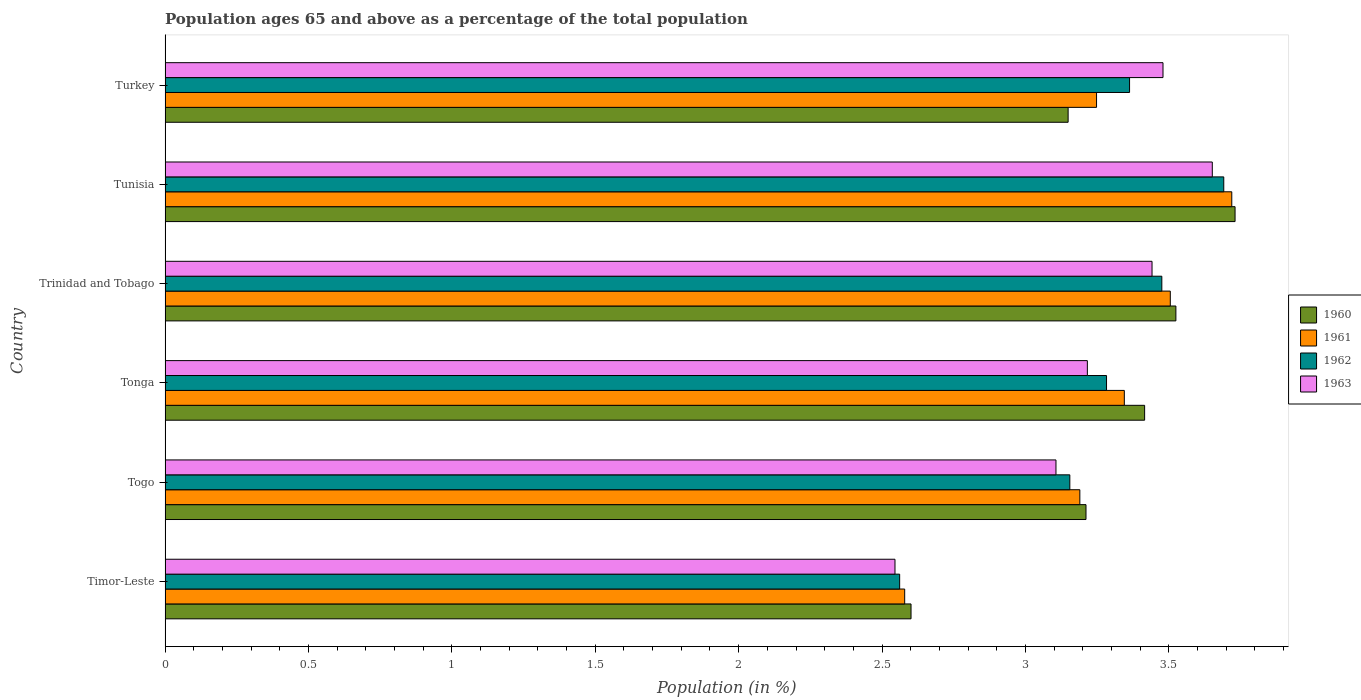How many groups of bars are there?
Keep it short and to the point. 6. Are the number of bars on each tick of the Y-axis equal?
Your answer should be compact. Yes. What is the label of the 3rd group of bars from the top?
Your response must be concise. Trinidad and Tobago. What is the percentage of the population ages 65 and above in 1963 in Timor-Leste?
Provide a succinct answer. 2.55. Across all countries, what is the maximum percentage of the population ages 65 and above in 1960?
Make the answer very short. 3.73. Across all countries, what is the minimum percentage of the population ages 65 and above in 1963?
Offer a very short reply. 2.55. In which country was the percentage of the population ages 65 and above in 1960 maximum?
Your response must be concise. Tunisia. In which country was the percentage of the population ages 65 and above in 1963 minimum?
Offer a terse response. Timor-Leste. What is the total percentage of the population ages 65 and above in 1963 in the graph?
Provide a short and direct response. 19.44. What is the difference between the percentage of the population ages 65 and above in 1962 in Timor-Leste and that in Tonga?
Provide a short and direct response. -0.72. What is the difference between the percentage of the population ages 65 and above in 1962 in Togo and the percentage of the population ages 65 and above in 1961 in Trinidad and Tobago?
Ensure brevity in your answer.  -0.35. What is the average percentage of the population ages 65 and above in 1963 per country?
Offer a terse response. 3.24. What is the difference between the percentage of the population ages 65 and above in 1963 and percentage of the population ages 65 and above in 1960 in Trinidad and Tobago?
Your answer should be very brief. -0.08. In how many countries, is the percentage of the population ages 65 and above in 1960 greater than 0.30000000000000004 ?
Keep it short and to the point. 6. What is the ratio of the percentage of the population ages 65 and above in 1963 in Togo to that in Tunisia?
Provide a short and direct response. 0.85. Is the percentage of the population ages 65 and above in 1962 in Tonga less than that in Turkey?
Offer a terse response. Yes. Is the difference between the percentage of the population ages 65 and above in 1963 in Timor-Leste and Trinidad and Tobago greater than the difference between the percentage of the population ages 65 and above in 1960 in Timor-Leste and Trinidad and Tobago?
Your answer should be compact. Yes. What is the difference between the highest and the second highest percentage of the population ages 65 and above in 1963?
Offer a terse response. 0.17. What is the difference between the highest and the lowest percentage of the population ages 65 and above in 1962?
Ensure brevity in your answer.  1.13. In how many countries, is the percentage of the population ages 65 and above in 1960 greater than the average percentage of the population ages 65 and above in 1960 taken over all countries?
Your response must be concise. 3. What does the 2nd bar from the bottom in Turkey represents?
Keep it short and to the point. 1961. How many bars are there?
Provide a short and direct response. 24. Does the graph contain any zero values?
Your response must be concise. No. Does the graph contain grids?
Provide a succinct answer. No. Where does the legend appear in the graph?
Your response must be concise. Center right. How many legend labels are there?
Your answer should be very brief. 4. How are the legend labels stacked?
Give a very brief answer. Vertical. What is the title of the graph?
Make the answer very short. Population ages 65 and above as a percentage of the total population. What is the label or title of the X-axis?
Your response must be concise. Population (in %). What is the label or title of the Y-axis?
Offer a very short reply. Country. What is the Population (in %) in 1960 in Timor-Leste?
Your answer should be compact. 2.6. What is the Population (in %) of 1961 in Timor-Leste?
Offer a very short reply. 2.58. What is the Population (in %) in 1962 in Timor-Leste?
Your response must be concise. 2.56. What is the Population (in %) in 1963 in Timor-Leste?
Provide a succinct answer. 2.55. What is the Population (in %) of 1960 in Togo?
Offer a very short reply. 3.21. What is the Population (in %) in 1961 in Togo?
Your response must be concise. 3.19. What is the Population (in %) in 1962 in Togo?
Your response must be concise. 3.15. What is the Population (in %) in 1963 in Togo?
Your response must be concise. 3.11. What is the Population (in %) of 1960 in Tonga?
Give a very brief answer. 3.42. What is the Population (in %) of 1961 in Tonga?
Offer a very short reply. 3.34. What is the Population (in %) of 1962 in Tonga?
Provide a succinct answer. 3.28. What is the Population (in %) in 1963 in Tonga?
Give a very brief answer. 3.22. What is the Population (in %) of 1960 in Trinidad and Tobago?
Offer a terse response. 3.52. What is the Population (in %) of 1961 in Trinidad and Tobago?
Provide a succinct answer. 3.51. What is the Population (in %) in 1962 in Trinidad and Tobago?
Ensure brevity in your answer.  3.48. What is the Population (in %) of 1963 in Trinidad and Tobago?
Give a very brief answer. 3.44. What is the Population (in %) in 1960 in Tunisia?
Give a very brief answer. 3.73. What is the Population (in %) of 1961 in Tunisia?
Provide a short and direct response. 3.72. What is the Population (in %) in 1962 in Tunisia?
Your answer should be very brief. 3.69. What is the Population (in %) of 1963 in Tunisia?
Offer a very short reply. 3.65. What is the Population (in %) of 1960 in Turkey?
Provide a short and direct response. 3.15. What is the Population (in %) in 1961 in Turkey?
Provide a short and direct response. 3.25. What is the Population (in %) in 1962 in Turkey?
Keep it short and to the point. 3.36. What is the Population (in %) in 1963 in Turkey?
Your answer should be very brief. 3.48. Across all countries, what is the maximum Population (in %) in 1960?
Give a very brief answer. 3.73. Across all countries, what is the maximum Population (in %) in 1961?
Provide a succinct answer. 3.72. Across all countries, what is the maximum Population (in %) of 1962?
Provide a short and direct response. 3.69. Across all countries, what is the maximum Population (in %) in 1963?
Ensure brevity in your answer.  3.65. Across all countries, what is the minimum Population (in %) in 1960?
Provide a short and direct response. 2.6. Across all countries, what is the minimum Population (in %) of 1961?
Keep it short and to the point. 2.58. Across all countries, what is the minimum Population (in %) of 1962?
Provide a short and direct response. 2.56. Across all countries, what is the minimum Population (in %) of 1963?
Offer a very short reply. 2.55. What is the total Population (in %) of 1960 in the graph?
Your answer should be compact. 19.63. What is the total Population (in %) in 1961 in the graph?
Keep it short and to the point. 19.59. What is the total Population (in %) of 1962 in the graph?
Offer a terse response. 19.53. What is the total Population (in %) in 1963 in the graph?
Offer a terse response. 19.44. What is the difference between the Population (in %) in 1960 in Timor-Leste and that in Togo?
Give a very brief answer. -0.61. What is the difference between the Population (in %) in 1961 in Timor-Leste and that in Togo?
Provide a short and direct response. -0.61. What is the difference between the Population (in %) of 1962 in Timor-Leste and that in Togo?
Make the answer very short. -0.59. What is the difference between the Population (in %) in 1963 in Timor-Leste and that in Togo?
Offer a terse response. -0.56. What is the difference between the Population (in %) in 1960 in Timor-Leste and that in Tonga?
Your answer should be compact. -0.81. What is the difference between the Population (in %) of 1961 in Timor-Leste and that in Tonga?
Provide a succinct answer. -0.77. What is the difference between the Population (in %) in 1962 in Timor-Leste and that in Tonga?
Make the answer very short. -0.72. What is the difference between the Population (in %) of 1963 in Timor-Leste and that in Tonga?
Give a very brief answer. -0.67. What is the difference between the Population (in %) of 1960 in Timor-Leste and that in Trinidad and Tobago?
Provide a succinct answer. -0.92. What is the difference between the Population (in %) in 1961 in Timor-Leste and that in Trinidad and Tobago?
Provide a succinct answer. -0.93. What is the difference between the Population (in %) of 1962 in Timor-Leste and that in Trinidad and Tobago?
Offer a terse response. -0.91. What is the difference between the Population (in %) of 1963 in Timor-Leste and that in Trinidad and Tobago?
Your response must be concise. -0.9. What is the difference between the Population (in %) of 1960 in Timor-Leste and that in Tunisia?
Your answer should be very brief. -1.13. What is the difference between the Population (in %) in 1961 in Timor-Leste and that in Tunisia?
Make the answer very short. -1.14. What is the difference between the Population (in %) of 1962 in Timor-Leste and that in Tunisia?
Provide a succinct answer. -1.13. What is the difference between the Population (in %) in 1963 in Timor-Leste and that in Tunisia?
Offer a terse response. -1.11. What is the difference between the Population (in %) in 1960 in Timor-Leste and that in Turkey?
Provide a short and direct response. -0.55. What is the difference between the Population (in %) of 1961 in Timor-Leste and that in Turkey?
Provide a short and direct response. -0.67. What is the difference between the Population (in %) of 1962 in Timor-Leste and that in Turkey?
Your answer should be compact. -0.8. What is the difference between the Population (in %) in 1963 in Timor-Leste and that in Turkey?
Offer a terse response. -0.93. What is the difference between the Population (in %) of 1960 in Togo and that in Tonga?
Ensure brevity in your answer.  -0.2. What is the difference between the Population (in %) in 1961 in Togo and that in Tonga?
Keep it short and to the point. -0.16. What is the difference between the Population (in %) of 1962 in Togo and that in Tonga?
Ensure brevity in your answer.  -0.13. What is the difference between the Population (in %) of 1963 in Togo and that in Tonga?
Provide a succinct answer. -0.11. What is the difference between the Population (in %) of 1960 in Togo and that in Trinidad and Tobago?
Your answer should be compact. -0.31. What is the difference between the Population (in %) of 1961 in Togo and that in Trinidad and Tobago?
Offer a very short reply. -0.32. What is the difference between the Population (in %) of 1962 in Togo and that in Trinidad and Tobago?
Your answer should be very brief. -0.32. What is the difference between the Population (in %) of 1963 in Togo and that in Trinidad and Tobago?
Your answer should be compact. -0.34. What is the difference between the Population (in %) in 1960 in Togo and that in Tunisia?
Make the answer very short. -0.52. What is the difference between the Population (in %) of 1961 in Togo and that in Tunisia?
Your answer should be very brief. -0.53. What is the difference between the Population (in %) of 1962 in Togo and that in Tunisia?
Offer a very short reply. -0.54. What is the difference between the Population (in %) in 1963 in Togo and that in Tunisia?
Offer a terse response. -0.55. What is the difference between the Population (in %) in 1960 in Togo and that in Turkey?
Ensure brevity in your answer.  0.06. What is the difference between the Population (in %) in 1961 in Togo and that in Turkey?
Offer a terse response. -0.06. What is the difference between the Population (in %) in 1962 in Togo and that in Turkey?
Ensure brevity in your answer.  -0.21. What is the difference between the Population (in %) of 1963 in Togo and that in Turkey?
Your response must be concise. -0.37. What is the difference between the Population (in %) in 1960 in Tonga and that in Trinidad and Tobago?
Ensure brevity in your answer.  -0.11. What is the difference between the Population (in %) of 1961 in Tonga and that in Trinidad and Tobago?
Make the answer very short. -0.16. What is the difference between the Population (in %) of 1962 in Tonga and that in Trinidad and Tobago?
Provide a succinct answer. -0.19. What is the difference between the Population (in %) of 1963 in Tonga and that in Trinidad and Tobago?
Ensure brevity in your answer.  -0.23. What is the difference between the Population (in %) of 1960 in Tonga and that in Tunisia?
Your response must be concise. -0.32. What is the difference between the Population (in %) of 1961 in Tonga and that in Tunisia?
Provide a short and direct response. -0.37. What is the difference between the Population (in %) of 1962 in Tonga and that in Tunisia?
Make the answer very short. -0.41. What is the difference between the Population (in %) in 1963 in Tonga and that in Tunisia?
Ensure brevity in your answer.  -0.44. What is the difference between the Population (in %) in 1960 in Tonga and that in Turkey?
Your answer should be compact. 0.27. What is the difference between the Population (in %) of 1961 in Tonga and that in Turkey?
Provide a succinct answer. 0.1. What is the difference between the Population (in %) in 1962 in Tonga and that in Turkey?
Your response must be concise. -0.08. What is the difference between the Population (in %) of 1963 in Tonga and that in Turkey?
Your answer should be compact. -0.26. What is the difference between the Population (in %) in 1960 in Trinidad and Tobago and that in Tunisia?
Ensure brevity in your answer.  -0.21. What is the difference between the Population (in %) of 1961 in Trinidad and Tobago and that in Tunisia?
Give a very brief answer. -0.21. What is the difference between the Population (in %) of 1962 in Trinidad and Tobago and that in Tunisia?
Offer a terse response. -0.22. What is the difference between the Population (in %) in 1963 in Trinidad and Tobago and that in Tunisia?
Your answer should be very brief. -0.21. What is the difference between the Population (in %) of 1960 in Trinidad and Tobago and that in Turkey?
Give a very brief answer. 0.38. What is the difference between the Population (in %) in 1961 in Trinidad and Tobago and that in Turkey?
Ensure brevity in your answer.  0.26. What is the difference between the Population (in %) in 1962 in Trinidad and Tobago and that in Turkey?
Offer a terse response. 0.11. What is the difference between the Population (in %) in 1963 in Trinidad and Tobago and that in Turkey?
Provide a short and direct response. -0.04. What is the difference between the Population (in %) of 1960 in Tunisia and that in Turkey?
Provide a short and direct response. 0.58. What is the difference between the Population (in %) in 1961 in Tunisia and that in Turkey?
Your answer should be very brief. 0.47. What is the difference between the Population (in %) in 1962 in Tunisia and that in Turkey?
Provide a short and direct response. 0.33. What is the difference between the Population (in %) in 1963 in Tunisia and that in Turkey?
Give a very brief answer. 0.17. What is the difference between the Population (in %) of 1960 in Timor-Leste and the Population (in %) of 1961 in Togo?
Make the answer very short. -0.59. What is the difference between the Population (in %) of 1960 in Timor-Leste and the Population (in %) of 1962 in Togo?
Provide a succinct answer. -0.55. What is the difference between the Population (in %) in 1960 in Timor-Leste and the Population (in %) in 1963 in Togo?
Your answer should be very brief. -0.51. What is the difference between the Population (in %) in 1961 in Timor-Leste and the Population (in %) in 1962 in Togo?
Give a very brief answer. -0.58. What is the difference between the Population (in %) of 1961 in Timor-Leste and the Population (in %) of 1963 in Togo?
Offer a terse response. -0.53. What is the difference between the Population (in %) of 1962 in Timor-Leste and the Population (in %) of 1963 in Togo?
Ensure brevity in your answer.  -0.55. What is the difference between the Population (in %) in 1960 in Timor-Leste and the Population (in %) in 1961 in Tonga?
Make the answer very short. -0.74. What is the difference between the Population (in %) in 1960 in Timor-Leste and the Population (in %) in 1962 in Tonga?
Keep it short and to the point. -0.68. What is the difference between the Population (in %) in 1960 in Timor-Leste and the Population (in %) in 1963 in Tonga?
Your answer should be compact. -0.61. What is the difference between the Population (in %) in 1961 in Timor-Leste and the Population (in %) in 1962 in Tonga?
Your answer should be very brief. -0.7. What is the difference between the Population (in %) in 1961 in Timor-Leste and the Population (in %) in 1963 in Tonga?
Give a very brief answer. -0.64. What is the difference between the Population (in %) in 1962 in Timor-Leste and the Population (in %) in 1963 in Tonga?
Your response must be concise. -0.65. What is the difference between the Population (in %) of 1960 in Timor-Leste and the Population (in %) of 1961 in Trinidad and Tobago?
Make the answer very short. -0.9. What is the difference between the Population (in %) in 1960 in Timor-Leste and the Population (in %) in 1962 in Trinidad and Tobago?
Your answer should be compact. -0.87. What is the difference between the Population (in %) of 1960 in Timor-Leste and the Population (in %) of 1963 in Trinidad and Tobago?
Provide a short and direct response. -0.84. What is the difference between the Population (in %) of 1961 in Timor-Leste and the Population (in %) of 1962 in Trinidad and Tobago?
Provide a succinct answer. -0.9. What is the difference between the Population (in %) of 1961 in Timor-Leste and the Population (in %) of 1963 in Trinidad and Tobago?
Offer a very short reply. -0.86. What is the difference between the Population (in %) in 1962 in Timor-Leste and the Population (in %) in 1963 in Trinidad and Tobago?
Provide a succinct answer. -0.88. What is the difference between the Population (in %) in 1960 in Timor-Leste and the Population (in %) in 1961 in Tunisia?
Offer a terse response. -1.12. What is the difference between the Population (in %) in 1960 in Timor-Leste and the Population (in %) in 1962 in Tunisia?
Offer a terse response. -1.09. What is the difference between the Population (in %) in 1960 in Timor-Leste and the Population (in %) in 1963 in Tunisia?
Provide a succinct answer. -1.05. What is the difference between the Population (in %) of 1961 in Timor-Leste and the Population (in %) of 1962 in Tunisia?
Offer a terse response. -1.11. What is the difference between the Population (in %) of 1961 in Timor-Leste and the Population (in %) of 1963 in Tunisia?
Make the answer very short. -1.07. What is the difference between the Population (in %) in 1962 in Timor-Leste and the Population (in %) in 1963 in Tunisia?
Make the answer very short. -1.09. What is the difference between the Population (in %) in 1960 in Timor-Leste and the Population (in %) in 1961 in Turkey?
Ensure brevity in your answer.  -0.65. What is the difference between the Population (in %) of 1960 in Timor-Leste and the Population (in %) of 1962 in Turkey?
Your answer should be compact. -0.76. What is the difference between the Population (in %) in 1960 in Timor-Leste and the Population (in %) in 1963 in Turkey?
Your answer should be very brief. -0.88. What is the difference between the Population (in %) of 1961 in Timor-Leste and the Population (in %) of 1962 in Turkey?
Your response must be concise. -0.78. What is the difference between the Population (in %) of 1961 in Timor-Leste and the Population (in %) of 1963 in Turkey?
Your answer should be compact. -0.9. What is the difference between the Population (in %) in 1962 in Timor-Leste and the Population (in %) in 1963 in Turkey?
Provide a succinct answer. -0.92. What is the difference between the Population (in %) in 1960 in Togo and the Population (in %) in 1961 in Tonga?
Provide a succinct answer. -0.13. What is the difference between the Population (in %) of 1960 in Togo and the Population (in %) of 1962 in Tonga?
Your answer should be very brief. -0.07. What is the difference between the Population (in %) in 1960 in Togo and the Population (in %) in 1963 in Tonga?
Offer a terse response. -0. What is the difference between the Population (in %) in 1961 in Togo and the Population (in %) in 1962 in Tonga?
Provide a succinct answer. -0.09. What is the difference between the Population (in %) in 1961 in Togo and the Population (in %) in 1963 in Tonga?
Make the answer very short. -0.03. What is the difference between the Population (in %) in 1962 in Togo and the Population (in %) in 1963 in Tonga?
Keep it short and to the point. -0.06. What is the difference between the Population (in %) in 1960 in Togo and the Population (in %) in 1961 in Trinidad and Tobago?
Make the answer very short. -0.29. What is the difference between the Population (in %) in 1960 in Togo and the Population (in %) in 1962 in Trinidad and Tobago?
Offer a very short reply. -0.26. What is the difference between the Population (in %) of 1960 in Togo and the Population (in %) of 1963 in Trinidad and Tobago?
Offer a terse response. -0.23. What is the difference between the Population (in %) in 1961 in Togo and the Population (in %) in 1962 in Trinidad and Tobago?
Give a very brief answer. -0.29. What is the difference between the Population (in %) of 1961 in Togo and the Population (in %) of 1963 in Trinidad and Tobago?
Provide a short and direct response. -0.25. What is the difference between the Population (in %) of 1962 in Togo and the Population (in %) of 1963 in Trinidad and Tobago?
Ensure brevity in your answer.  -0.29. What is the difference between the Population (in %) in 1960 in Togo and the Population (in %) in 1961 in Tunisia?
Offer a terse response. -0.51. What is the difference between the Population (in %) of 1960 in Togo and the Population (in %) of 1962 in Tunisia?
Keep it short and to the point. -0.48. What is the difference between the Population (in %) in 1960 in Togo and the Population (in %) in 1963 in Tunisia?
Ensure brevity in your answer.  -0.44. What is the difference between the Population (in %) of 1961 in Togo and the Population (in %) of 1962 in Tunisia?
Give a very brief answer. -0.5. What is the difference between the Population (in %) of 1961 in Togo and the Population (in %) of 1963 in Tunisia?
Your answer should be compact. -0.46. What is the difference between the Population (in %) of 1962 in Togo and the Population (in %) of 1963 in Tunisia?
Your answer should be very brief. -0.5. What is the difference between the Population (in %) of 1960 in Togo and the Population (in %) of 1961 in Turkey?
Your answer should be compact. -0.04. What is the difference between the Population (in %) in 1960 in Togo and the Population (in %) in 1962 in Turkey?
Your answer should be very brief. -0.15. What is the difference between the Population (in %) in 1960 in Togo and the Population (in %) in 1963 in Turkey?
Offer a terse response. -0.27. What is the difference between the Population (in %) in 1961 in Togo and the Population (in %) in 1962 in Turkey?
Offer a terse response. -0.17. What is the difference between the Population (in %) of 1961 in Togo and the Population (in %) of 1963 in Turkey?
Keep it short and to the point. -0.29. What is the difference between the Population (in %) of 1962 in Togo and the Population (in %) of 1963 in Turkey?
Offer a very short reply. -0.32. What is the difference between the Population (in %) in 1960 in Tonga and the Population (in %) in 1961 in Trinidad and Tobago?
Provide a succinct answer. -0.09. What is the difference between the Population (in %) of 1960 in Tonga and the Population (in %) of 1962 in Trinidad and Tobago?
Keep it short and to the point. -0.06. What is the difference between the Population (in %) in 1960 in Tonga and the Population (in %) in 1963 in Trinidad and Tobago?
Make the answer very short. -0.03. What is the difference between the Population (in %) in 1961 in Tonga and the Population (in %) in 1962 in Trinidad and Tobago?
Give a very brief answer. -0.13. What is the difference between the Population (in %) of 1961 in Tonga and the Population (in %) of 1963 in Trinidad and Tobago?
Make the answer very short. -0.1. What is the difference between the Population (in %) in 1962 in Tonga and the Population (in %) in 1963 in Trinidad and Tobago?
Make the answer very short. -0.16. What is the difference between the Population (in %) in 1960 in Tonga and the Population (in %) in 1961 in Tunisia?
Your answer should be very brief. -0.3. What is the difference between the Population (in %) in 1960 in Tonga and the Population (in %) in 1962 in Tunisia?
Give a very brief answer. -0.28. What is the difference between the Population (in %) of 1960 in Tonga and the Population (in %) of 1963 in Tunisia?
Provide a succinct answer. -0.24. What is the difference between the Population (in %) of 1961 in Tonga and the Population (in %) of 1962 in Tunisia?
Your answer should be compact. -0.35. What is the difference between the Population (in %) of 1961 in Tonga and the Population (in %) of 1963 in Tunisia?
Offer a terse response. -0.31. What is the difference between the Population (in %) of 1962 in Tonga and the Population (in %) of 1963 in Tunisia?
Your answer should be compact. -0.37. What is the difference between the Population (in %) of 1960 in Tonga and the Population (in %) of 1961 in Turkey?
Your response must be concise. 0.17. What is the difference between the Population (in %) in 1960 in Tonga and the Population (in %) in 1962 in Turkey?
Ensure brevity in your answer.  0.05. What is the difference between the Population (in %) of 1960 in Tonga and the Population (in %) of 1963 in Turkey?
Ensure brevity in your answer.  -0.06. What is the difference between the Population (in %) of 1961 in Tonga and the Population (in %) of 1962 in Turkey?
Your answer should be very brief. -0.02. What is the difference between the Population (in %) in 1961 in Tonga and the Population (in %) in 1963 in Turkey?
Your answer should be compact. -0.13. What is the difference between the Population (in %) of 1962 in Tonga and the Population (in %) of 1963 in Turkey?
Provide a succinct answer. -0.2. What is the difference between the Population (in %) of 1960 in Trinidad and Tobago and the Population (in %) of 1961 in Tunisia?
Your response must be concise. -0.19. What is the difference between the Population (in %) of 1960 in Trinidad and Tobago and the Population (in %) of 1962 in Tunisia?
Your response must be concise. -0.17. What is the difference between the Population (in %) in 1960 in Trinidad and Tobago and the Population (in %) in 1963 in Tunisia?
Your response must be concise. -0.13. What is the difference between the Population (in %) of 1961 in Trinidad and Tobago and the Population (in %) of 1962 in Tunisia?
Keep it short and to the point. -0.19. What is the difference between the Population (in %) of 1961 in Trinidad and Tobago and the Population (in %) of 1963 in Tunisia?
Keep it short and to the point. -0.15. What is the difference between the Population (in %) of 1962 in Trinidad and Tobago and the Population (in %) of 1963 in Tunisia?
Offer a terse response. -0.18. What is the difference between the Population (in %) in 1960 in Trinidad and Tobago and the Population (in %) in 1961 in Turkey?
Ensure brevity in your answer.  0.28. What is the difference between the Population (in %) in 1960 in Trinidad and Tobago and the Population (in %) in 1962 in Turkey?
Your answer should be compact. 0.16. What is the difference between the Population (in %) of 1960 in Trinidad and Tobago and the Population (in %) of 1963 in Turkey?
Provide a succinct answer. 0.04. What is the difference between the Population (in %) of 1961 in Trinidad and Tobago and the Population (in %) of 1962 in Turkey?
Your response must be concise. 0.14. What is the difference between the Population (in %) in 1961 in Trinidad and Tobago and the Population (in %) in 1963 in Turkey?
Your answer should be very brief. 0.03. What is the difference between the Population (in %) in 1962 in Trinidad and Tobago and the Population (in %) in 1963 in Turkey?
Offer a very short reply. -0. What is the difference between the Population (in %) of 1960 in Tunisia and the Population (in %) of 1961 in Turkey?
Give a very brief answer. 0.48. What is the difference between the Population (in %) of 1960 in Tunisia and the Population (in %) of 1962 in Turkey?
Offer a very short reply. 0.37. What is the difference between the Population (in %) of 1960 in Tunisia and the Population (in %) of 1963 in Turkey?
Offer a terse response. 0.25. What is the difference between the Population (in %) of 1961 in Tunisia and the Population (in %) of 1962 in Turkey?
Ensure brevity in your answer.  0.36. What is the difference between the Population (in %) in 1961 in Tunisia and the Population (in %) in 1963 in Turkey?
Provide a short and direct response. 0.24. What is the difference between the Population (in %) in 1962 in Tunisia and the Population (in %) in 1963 in Turkey?
Your response must be concise. 0.21. What is the average Population (in %) of 1960 per country?
Ensure brevity in your answer.  3.27. What is the average Population (in %) of 1961 per country?
Your answer should be compact. 3.26. What is the average Population (in %) in 1962 per country?
Give a very brief answer. 3.25. What is the average Population (in %) in 1963 per country?
Provide a succinct answer. 3.24. What is the difference between the Population (in %) of 1960 and Population (in %) of 1961 in Timor-Leste?
Your answer should be very brief. 0.02. What is the difference between the Population (in %) of 1960 and Population (in %) of 1962 in Timor-Leste?
Provide a short and direct response. 0.04. What is the difference between the Population (in %) of 1960 and Population (in %) of 1963 in Timor-Leste?
Provide a short and direct response. 0.06. What is the difference between the Population (in %) of 1961 and Population (in %) of 1962 in Timor-Leste?
Provide a succinct answer. 0.02. What is the difference between the Population (in %) of 1961 and Population (in %) of 1963 in Timor-Leste?
Provide a short and direct response. 0.03. What is the difference between the Population (in %) in 1962 and Population (in %) in 1963 in Timor-Leste?
Ensure brevity in your answer.  0.02. What is the difference between the Population (in %) in 1960 and Population (in %) in 1961 in Togo?
Make the answer very short. 0.02. What is the difference between the Population (in %) of 1960 and Population (in %) of 1962 in Togo?
Your answer should be very brief. 0.06. What is the difference between the Population (in %) in 1960 and Population (in %) in 1963 in Togo?
Your response must be concise. 0.1. What is the difference between the Population (in %) of 1961 and Population (in %) of 1962 in Togo?
Offer a terse response. 0.04. What is the difference between the Population (in %) of 1961 and Population (in %) of 1963 in Togo?
Keep it short and to the point. 0.08. What is the difference between the Population (in %) of 1962 and Population (in %) of 1963 in Togo?
Your answer should be compact. 0.05. What is the difference between the Population (in %) in 1960 and Population (in %) in 1961 in Tonga?
Ensure brevity in your answer.  0.07. What is the difference between the Population (in %) in 1960 and Population (in %) in 1962 in Tonga?
Your answer should be compact. 0.13. What is the difference between the Population (in %) of 1960 and Population (in %) of 1963 in Tonga?
Provide a short and direct response. 0.2. What is the difference between the Population (in %) of 1961 and Population (in %) of 1962 in Tonga?
Your answer should be compact. 0.06. What is the difference between the Population (in %) of 1961 and Population (in %) of 1963 in Tonga?
Provide a short and direct response. 0.13. What is the difference between the Population (in %) in 1962 and Population (in %) in 1963 in Tonga?
Your response must be concise. 0.07. What is the difference between the Population (in %) of 1960 and Population (in %) of 1961 in Trinidad and Tobago?
Offer a terse response. 0.02. What is the difference between the Population (in %) in 1960 and Population (in %) in 1962 in Trinidad and Tobago?
Provide a succinct answer. 0.05. What is the difference between the Population (in %) in 1960 and Population (in %) in 1963 in Trinidad and Tobago?
Keep it short and to the point. 0.08. What is the difference between the Population (in %) of 1961 and Population (in %) of 1962 in Trinidad and Tobago?
Your answer should be very brief. 0.03. What is the difference between the Population (in %) of 1961 and Population (in %) of 1963 in Trinidad and Tobago?
Your answer should be very brief. 0.06. What is the difference between the Population (in %) in 1962 and Population (in %) in 1963 in Trinidad and Tobago?
Offer a terse response. 0.03. What is the difference between the Population (in %) of 1960 and Population (in %) of 1961 in Tunisia?
Provide a short and direct response. 0.01. What is the difference between the Population (in %) of 1960 and Population (in %) of 1962 in Tunisia?
Your response must be concise. 0.04. What is the difference between the Population (in %) of 1960 and Population (in %) of 1963 in Tunisia?
Your answer should be very brief. 0.08. What is the difference between the Population (in %) of 1961 and Population (in %) of 1962 in Tunisia?
Your answer should be very brief. 0.03. What is the difference between the Population (in %) of 1961 and Population (in %) of 1963 in Tunisia?
Make the answer very short. 0.07. What is the difference between the Population (in %) in 1962 and Population (in %) in 1963 in Tunisia?
Your response must be concise. 0.04. What is the difference between the Population (in %) in 1960 and Population (in %) in 1961 in Turkey?
Offer a terse response. -0.1. What is the difference between the Population (in %) in 1960 and Population (in %) in 1962 in Turkey?
Your answer should be compact. -0.21. What is the difference between the Population (in %) of 1960 and Population (in %) of 1963 in Turkey?
Provide a succinct answer. -0.33. What is the difference between the Population (in %) of 1961 and Population (in %) of 1962 in Turkey?
Offer a terse response. -0.12. What is the difference between the Population (in %) of 1961 and Population (in %) of 1963 in Turkey?
Provide a short and direct response. -0.23. What is the difference between the Population (in %) in 1962 and Population (in %) in 1963 in Turkey?
Offer a terse response. -0.12. What is the ratio of the Population (in %) in 1960 in Timor-Leste to that in Togo?
Ensure brevity in your answer.  0.81. What is the ratio of the Population (in %) of 1961 in Timor-Leste to that in Togo?
Your response must be concise. 0.81. What is the ratio of the Population (in %) of 1962 in Timor-Leste to that in Togo?
Offer a very short reply. 0.81. What is the ratio of the Population (in %) in 1963 in Timor-Leste to that in Togo?
Keep it short and to the point. 0.82. What is the ratio of the Population (in %) in 1960 in Timor-Leste to that in Tonga?
Keep it short and to the point. 0.76. What is the ratio of the Population (in %) in 1961 in Timor-Leste to that in Tonga?
Provide a short and direct response. 0.77. What is the ratio of the Population (in %) of 1962 in Timor-Leste to that in Tonga?
Provide a succinct answer. 0.78. What is the ratio of the Population (in %) of 1963 in Timor-Leste to that in Tonga?
Keep it short and to the point. 0.79. What is the ratio of the Population (in %) of 1960 in Timor-Leste to that in Trinidad and Tobago?
Offer a very short reply. 0.74. What is the ratio of the Population (in %) in 1961 in Timor-Leste to that in Trinidad and Tobago?
Give a very brief answer. 0.74. What is the ratio of the Population (in %) of 1962 in Timor-Leste to that in Trinidad and Tobago?
Keep it short and to the point. 0.74. What is the ratio of the Population (in %) in 1963 in Timor-Leste to that in Trinidad and Tobago?
Your answer should be compact. 0.74. What is the ratio of the Population (in %) in 1960 in Timor-Leste to that in Tunisia?
Offer a terse response. 0.7. What is the ratio of the Population (in %) of 1961 in Timor-Leste to that in Tunisia?
Make the answer very short. 0.69. What is the ratio of the Population (in %) in 1962 in Timor-Leste to that in Tunisia?
Provide a short and direct response. 0.69. What is the ratio of the Population (in %) of 1963 in Timor-Leste to that in Tunisia?
Provide a short and direct response. 0.7. What is the ratio of the Population (in %) of 1960 in Timor-Leste to that in Turkey?
Keep it short and to the point. 0.83. What is the ratio of the Population (in %) of 1961 in Timor-Leste to that in Turkey?
Your answer should be compact. 0.79. What is the ratio of the Population (in %) in 1962 in Timor-Leste to that in Turkey?
Provide a short and direct response. 0.76. What is the ratio of the Population (in %) in 1963 in Timor-Leste to that in Turkey?
Keep it short and to the point. 0.73. What is the ratio of the Population (in %) of 1960 in Togo to that in Tonga?
Offer a very short reply. 0.94. What is the ratio of the Population (in %) in 1961 in Togo to that in Tonga?
Provide a succinct answer. 0.95. What is the ratio of the Population (in %) of 1962 in Togo to that in Tonga?
Your answer should be compact. 0.96. What is the ratio of the Population (in %) of 1963 in Togo to that in Tonga?
Ensure brevity in your answer.  0.97. What is the ratio of the Population (in %) of 1960 in Togo to that in Trinidad and Tobago?
Ensure brevity in your answer.  0.91. What is the ratio of the Population (in %) of 1961 in Togo to that in Trinidad and Tobago?
Make the answer very short. 0.91. What is the ratio of the Population (in %) of 1962 in Togo to that in Trinidad and Tobago?
Your response must be concise. 0.91. What is the ratio of the Population (in %) in 1963 in Togo to that in Trinidad and Tobago?
Make the answer very short. 0.9. What is the ratio of the Population (in %) in 1960 in Togo to that in Tunisia?
Make the answer very short. 0.86. What is the ratio of the Population (in %) in 1961 in Togo to that in Tunisia?
Provide a succinct answer. 0.86. What is the ratio of the Population (in %) in 1962 in Togo to that in Tunisia?
Provide a succinct answer. 0.85. What is the ratio of the Population (in %) in 1963 in Togo to that in Tunisia?
Give a very brief answer. 0.85. What is the ratio of the Population (in %) of 1960 in Togo to that in Turkey?
Provide a succinct answer. 1.02. What is the ratio of the Population (in %) of 1961 in Togo to that in Turkey?
Offer a terse response. 0.98. What is the ratio of the Population (in %) in 1962 in Togo to that in Turkey?
Keep it short and to the point. 0.94. What is the ratio of the Population (in %) of 1963 in Togo to that in Turkey?
Offer a terse response. 0.89. What is the ratio of the Population (in %) of 1960 in Tonga to that in Trinidad and Tobago?
Your answer should be compact. 0.97. What is the ratio of the Population (in %) of 1961 in Tonga to that in Trinidad and Tobago?
Make the answer very short. 0.95. What is the ratio of the Population (in %) in 1962 in Tonga to that in Trinidad and Tobago?
Your answer should be very brief. 0.94. What is the ratio of the Population (in %) in 1963 in Tonga to that in Trinidad and Tobago?
Ensure brevity in your answer.  0.93. What is the ratio of the Population (in %) in 1960 in Tonga to that in Tunisia?
Offer a very short reply. 0.92. What is the ratio of the Population (in %) of 1961 in Tonga to that in Tunisia?
Your answer should be very brief. 0.9. What is the ratio of the Population (in %) in 1962 in Tonga to that in Tunisia?
Provide a short and direct response. 0.89. What is the ratio of the Population (in %) in 1963 in Tonga to that in Tunisia?
Provide a short and direct response. 0.88. What is the ratio of the Population (in %) of 1960 in Tonga to that in Turkey?
Offer a terse response. 1.08. What is the ratio of the Population (in %) of 1961 in Tonga to that in Turkey?
Offer a terse response. 1.03. What is the ratio of the Population (in %) of 1962 in Tonga to that in Turkey?
Provide a succinct answer. 0.98. What is the ratio of the Population (in %) of 1963 in Tonga to that in Turkey?
Make the answer very short. 0.92. What is the ratio of the Population (in %) in 1960 in Trinidad and Tobago to that in Tunisia?
Your answer should be compact. 0.94. What is the ratio of the Population (in %) of 1961 in Trinidad and Tobago to that in Tunisia?
Make the answer very short. 0.94. What is the ratio of the Population (in %) in 1962 in Trinidad and Tobago to that in Tunisia?
Offer a terse response. 0.94. What is the ratio of the Population (in %) of 1963 in Trinidad and Tobago to that in Tunisia?
Ensure brevity in your answer.  0.94. What is the ratio of the Population (in %) in 1960 in Trinidad and Tobago to that in Turkey?
Make the answer very short. 1.12. What is the ratio of the Population (in %) in 1961 in Trinidad and Tobago to that in Turkey?
Keep it short and to the point. 1.08. What is the ratio of the Population (in %) in 1962 in Trinidad and Tobago to that in Turkey?
Your response must be concise. 1.03. What is the ratio of the Population (in %) of 1960 in Tunisia to that in Turkey?
Make the answer very short. 1.18. What is the ratio of the Population (in %) of 1961 in Tunisia to that in Turkey?
Ensure brevity in your answer.  1.15. What is the ratio of the Population (in %) of 1962 in Tunisia to that in Turkey?
Your answer should be compact. 1.1. What is the ratio of the Population (in %) of 1963 in Tunisia to that in Turkey?
Your answer should be very brief. 1.05. What is the difference between the highest and the second highest Population (in %) in 1960?
Offer a very short reply. 0.21. What is the difference between the highest and the second highest Population (in %) in 1961?
Ensure brevity in your answer.  0.21. What is the difference between the highest and the second highest Population (in %) in 1962?
Your response must be concise. 0.22. What is the difference between the highest and the second highest Population (in %) of 1963?
Offer a terse response. 0.17. What is the difference between the highest and the lowest Population (in %) in 1960?
Make the answer very short. 1.13. What is the difference between the highest and the lowest Population (in %) of 1961?
Your answer should be compact. 1.14. What is the difference between the highest and the lowest Population (in %) of 1962?
Make the answer very short. 1.13. What is the difference between the highest and the lowest Population (in %) of 1963?
Provide a short and direct response. 1.11. 